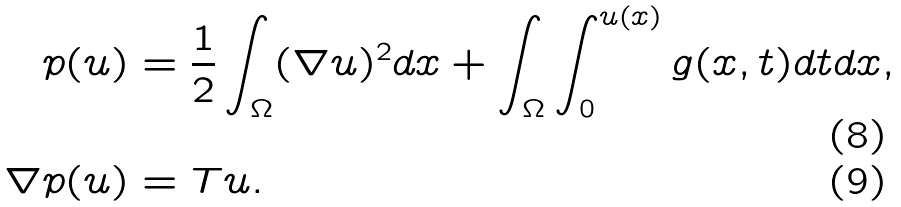Convert formula to latex. <formula><loc_0><loc_0><loc_500><loc_500>p ( u ) & = \frac { 1 } { 2 } \int _ { \Omega } ( \nabla u ) ^ { 2 } d x + \int _ { \Omega } \int _ { 0 } ^ { u ( x ) } g ( x , t ) d t d x , \\ \nabla p ( u ) & = T u .</formula> 